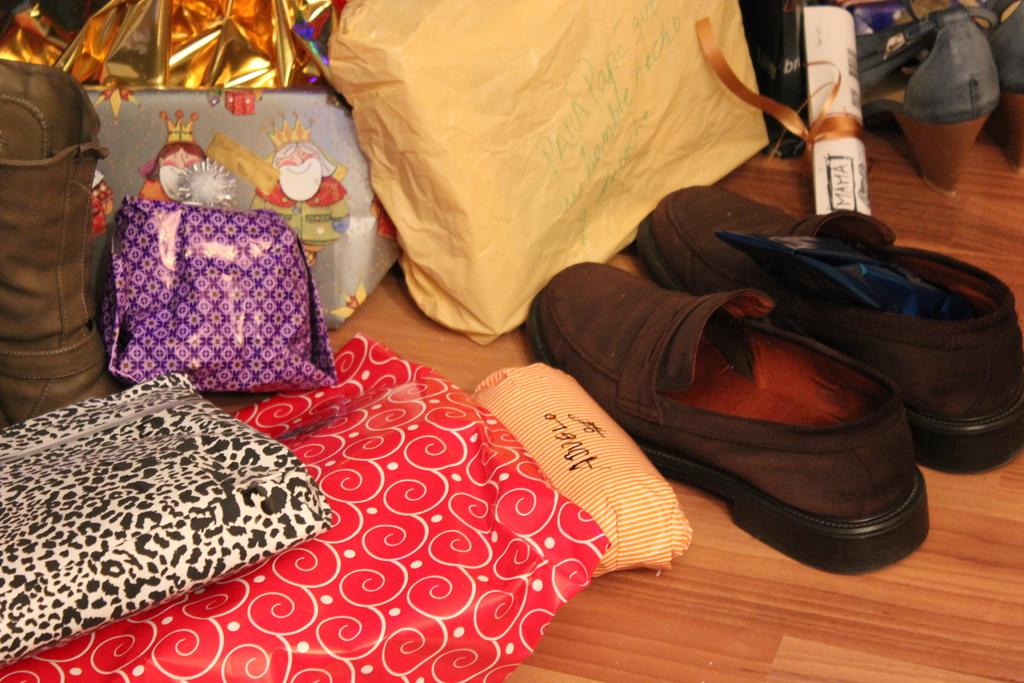What type of surface is visible in the image? There is a wooden surface in the image. What can be seen on top of the wooden surface? Foot wears and gift wrappers are present on the wooden surface. Is there any covering on the wooden surface? Yes, there is a cover on the wooden surface. What type of material is visible on the wooden surface? Lace is visible on the wooden surface. Can you describe any other items on the wooden surface? There are other unspecified items on the wooden surface. How does the stomach of the goldfish in the image appear? There is no goldfish present in the image, so it is not possible to describe its stomach. 